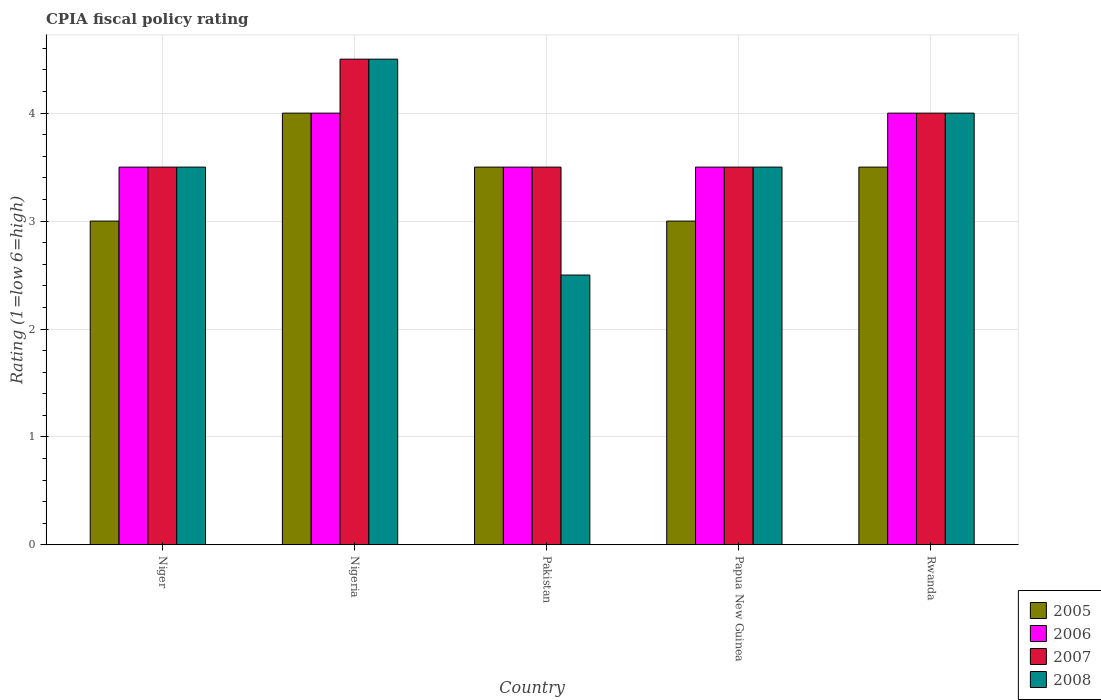How many different coloured bars are there?
Your response must be concise. 4. How many groups of bars are there?
Offer a very short reply. 5. Are the number of bars per tick equal to the number of legend labels?
Ensure brevity in your answer.  Yes. How many bars are there on the 5th tick from the left?
Ensure brevity in your answer.  4. What is the label of the 5th group of bars from the left?
Provide a short and direct response. Rwanda. In which country was the CPIA rating in 2008 maximum?
Provide a succinct answer. Nigeria. In which country was the CPIA rating in 2007 minimum?
Your answer should be very brief. Niger. What is the difference between the CPIA rating in 2008 in Papua New Guinea and that in Rwanda?
Provide a short and direct response. -0.5. What is the difference between the CPIA rating in 2006 in Papua New Guinea and the CPIA rating in 2007 in Niger?
Your response must be concise. 0. What is the average CPIA rating in 2007 per country?
Provide a short and direct response. 3.8. In how many countries, is the CPIA rating in 2007 greater than 4?
Make the answer very short. 1. What is the ratio of the CPIA rating in 2005 in Nigeria to that in Rwanda?
Offer a terse response. 1.14. Is the sum of the CPIA rating in 2006 in Niger and Nigeria greater than the maximum CPIA rating in 2007 across all countries?
Make the answer very short. Yes. Is it the case that in every country, the sum of the CPIA rating in 2006 and CPIA rating in 2007 is greater than the sum of CPIA rating in 2008 and CPIA rating in 2005?
Provide a short and direct response. No. Is it the case that in every country, the sum of the CPIA rating in 2007 and CPIA rating in 2006 is greater than the CPIA rating in 2008?
Provide a short and direct response. Yes. What is the difference between two consecutive major ticks on the Y-axis?
Your response must be concise. 1. How many legend labels are there?
Provide a short and direct response. 4. How are the legend labels stacked?
Your response must be concise. Vertical. What is the title of the graph?
Keep it short and to the point. CPIA fiscal policy rating. Does "1998" appear as one of the legend labels in the graph?
Your response must be concise. No. What is the label or title of the X-axis?
Give a very brief answer. Country. What is the label or title of the Y-axis?
Provide a succinct answer. Rating (1=low 6=high). What is the Rating (1=low 6=high) in 2006 in Nigeria?
Provide a short and direct response. 4. What is the Rating (1=low 6=high) of 2008 in Nigeria?
Offer a terse response. 4.5. What is the Rating (1=low 6=high) in 2005 in Pakistan?
Keep it short and to the point. 3.5. What is the Rating (1=low 6=high) of 2007 in Pakistan?
Your answer should be very brief. 3.5. What is the Rating (1=low 6=high) of 2006 in Papua New Guinea?
Give a very brief answer. 3.5. What is the Rating (1=low 6=high) of 2007 in Papua New Guinea?
Offer a terse response. 3.5. What is the Rating (1=low 6=high) in 2006 in Rwanda?
Offer a terse response. 4. What is the Rating (1=low 6=high) of 2007 in Rwanda?
Your answer should be very brief. 4. Across all countries, what is the maximum Rating (1=low 6=high) of 2006?
Provide a short and direct response. 4. Across all countries, what is the maximum Rating (1=low 6=high) in 2008?
Your answer should be very brief. 4.5. Across all countries, what is the minimum Rating (1=low 6=high) of 2005?
Provide a succinct answer. 3. Across all countries, what is the minimum Rating (1=low 6=high) of 2007?
Give a very brief answer. 3.5. Across all countries, what is the minimum Rating (1=low 6=high) in 2008?
Give a very brief answer. 2.5. What is the total Rating (1=low 6=high) of 2005 in the graph?
Give a very brief answer. 17. What is the total Rating (1=low 6=high) of 2006 in the graph?
Ensure brevity in your answer.  18.5. What is the difference between the Rating (1=low 6=high) of 2005 in Niger and that in Nigeria?
Provide a short and direct response. -1. What is the difference between the Rating (1=low 6=high) in 2007 in Niger and that in Nigeria?
Offer a very short reply. -1. What is the difference between the Rating (1=low 6=high) of 2008 in Niger and that in Nigeria?
Your response must be concise. -1. What is the difference between the Rating (1=low 6=high) in 2006 in Niger and that in Pakistan?
Ensure brevity in your answer.  0. What is the difference between the Rating (1=low 6=high) of 2007 in Niger and that in Pakistan?
Offer a terse response. 0. What is the difference between the Rating (1=low 6=high) of 2005 in Niger and that in Papua New Guinea?
Keep it short and to the point. 0. What is the difference between the Rating (1=low 6=high) of 2007 in Niger and that in Papua New Guinea?
Your answer should be very brief. 0. What is the difference between the Rating (1=low 6=high) of 2008 in Niger and that in Papua New Guinea?
Ensure brevity in your answer.  0. What is the difference between the Rating (1=low 6=high) of 2006 in Niger and that in Rwanda?
Ensure brevity in your answer.  -0.5. What is the difference between the Rating (1=low 6=high) in 2007 in Niger and that in Rwanda?
Your answer should be very brief. -0.5. What is the difference between the Rating (1=low 6=high) in 2008 in Niger and that in Rwanda?
Provide a succinct answer. -0.5. What is the difference between the Rating (1=low 6=high) of 2005 in Nigeria and that in Pakistan?
Ensure brevity in your answer.  0.5. What is the difference between the Rating (1=low 6=high) of 2006 in Nigeria and that in Pakistan?
Your response must be concise. 0.5. What is the difference between the Rating (1=low 6=high) in 2007 in Nigeria and that in Pakistan?
Give a very brief answer. 1. What is the difference between the Rating (1=low 6=high) in 2006 in Nigeria and that in Papua New Guinea?
Ensure brevity in your answer.  0.5. What is the difference between the Rating (1=low 6=high) in 2007 in Nigeria and that in Papua New Guinea?
Your response must be concise. 1. What is the difference between the Rating (1=low 6=high) of 2005 in Nigeria and that in Rwanda?
Make the answer very short. 0.5. What is the difference between the Rating (1=low 6=high) of 2007 in Nigeria and that in Rwanda?
Offer a terse response. 0.5. What is the difference between the Rating (1=low 6=high) in 2008 in Nigeria and that in Rwanda?
Ensure brevity in your answer.  0.5. What is the difference between the Rating (1=low 6=high) in 2005 in Pakistan and that in Papua New Guinea?
Keep it short and to the point. 0.5. What is the difference between the Rating (1=low 6=high) of 2006 in Pakistan and that in Papua New Guinea?
Provide a short and direct response. 0. What is the difference between the Rating (1=low 6=high) in 2007 in Pakistan and that in Papua New Guinea?
Your answer should be compact. 0. What is the difference between the Rating (1=low 6=high) in 2005 in Pakistan and that in Rwanda?
Your response must be concise. 0. What is the difference between the Rating (1=low 6=high) in 2006 in Pakistan and that in Rwanda?
Offer a very short reply. -0.5. What is the difference between the Rating (1=low 6=high) in 2007 in Pakistan and that in Rwanda?
Offer a very short reply. -0.5. What is the difference between the Rating (1=low 6=high) in 2008 in Pakistan and that in Rwanda?
Offer a terse response. -1.5. What is the difference between the Rating (1=low 6=high) of 2006 in Papua New Guinea and that in Rwanda?
Your answer should be compact. -0.5. What is the difference between the Rating (1=low 6=high) of 2007 in Papua New Guinea and that in Rwanda?
Offer a terse response. -0.5. What is the difference between the Rating (1=low 6=high) in 2008 in Papua New Guinea and that in Rwanda?
Make the answer very short. -0.5. What is the difference between the Rating (1=low 6=high) in 2005 in Niger and the Rating (1=low 6=high) in 2008 in Nigeria?
Offer a terse response. -1.5. What is the difference between the Rating (1=low 6=high) in 2006 in Niger and the Rating (1=low 6=high) in 2007 in Nigeria?
Offer a terse response. -1. What is the difference between the Rating (1=low 6=high) in 2007 in Niger and the Rating (1=low 6=high) in 2008 in Nigeria?
Your response must be concise. -1. What is the difference between the Rating (1=low 6=high) of 2005 in Niger and the Rating (1=low 6=high) of 2007 in Pakistan?
Provide a short and direct response. -0.5. What is the difference between the Rating (1=low 6=high) of 2005 in Niger and the Rating (1=low 6=high) of 2006 in Papua New Guinea?
Your answer should be very brief. -0.5. What is the difference between the Rating (1=low 6=high) of 2005 in Niger and the Rating (1=low 6=high) of 2007 in Papua New Guinea?
Provide a short and direct response. -0.5. What is the difference between the Rating (1=low 6=high) of 2005 in Niger and the Rating (1=low 6=high) of 2008 in Papua New Guinea?
Offer a terse response. -0.5. What is the difference between the Rating (1=low 6=high) of 2006 in Niger and the Rating (1=low 6=high) of 2007 in Papua New Guinea?
Provide a succinct answer. 0. What is the difference between the Rating (1=low 6=high) of 2007 in Niger and the Rating (1=low 6=high) of 2008 in Papua New Guinea?
Offer a very short reply. 0. What is the difference between the Rating (1=low 6=high) in 2005 in Niger and the Rating (1=low 6=high) in 2007 in Rwanda?
Your answer should be very brief. -1. What is the difference between the Rating (1=low 6=high) in 2005 in Niger and the Rating (1=low 6=high) in 2008 in Rwanda?
Your answer should be compact. -1. What is the difference between the Rating (1=low 6=high) in 2006 in Niger and the Rating (1=low 6=high) in 2007 in Rwanda?
Ensure brevity in your answer.  -0.5. What is the difference between the Rating (1=low 6=high) of 2007 in Niger and the Rating (1=low 6=high) of 2008 in Rwanda?
Offer a terse response. -0.5. What is the difference between the Rating (1=low 6=high) in 2005 in Nigeria and the Rating (1=low 6=high) in 2007 in Pakistan?
Your answer should be compact. 0.5. What is the difference between the Rating (1=low 6=high) in 2006 in Nigeria and the Rating (1=low 6=high) in 2008 in Pakistan?
Your answer should be compact. 1.5. What is the difference between the Rating (1=low 6=high) in 2005 in Nigeria and the Rating (1=low 6=high) in 2006 in Papua New Guinea?
Ensure brevity in your answer.  0.5. What is the difference between the Rating (1=low 6=high) of 2005 in Nigeria and the Rating (1=low 6=high) of 2007 in Papua New Guinea?
Your answer should be compact. 0.5. What is the difference between the Rating (1=low 6=high) in 2005 in Nigeria and the Rating (1=low 6=high) in 2008 in Papua New Guinea?
Provide a succinct answer. 0.5. What is the difference between the Rating (1=low 6=high) in 2006 in Nigeria and the Rating (1=low 6=high) in 2007 in Papua New Guinea?
Offer a very short reply. 0.5. What is the difference between the Rating (1=low 6=high) in 2006 in Nigeria and the Rating (1=low 6=high) in 2008 in Papua New Guinea?
Your response must be concise. 0.5. What is the difference between the Rating (1=low 6=high) of 2007 in Nigeria and the Rating (1=low 6=high) of 2008 in Papua New Guinea?
Keep it short and to the point. 1. What is the difference between the Rating (1=low 6=high) of 2005 in Nigeria and the Rating (1=low 6=high) of 2006 in Rwanda?
Your answer should be very brief. 0. What is the difference between the Rating (1=low 6=high) of 2006 in Nigeria and the Rating (1=low 6=high) of 2007 in Rwanda?
Offer a very short reply. 0. What is the difference between the Rating (1=low 6=high) of 2006 in Nigeria and the Rating (1=low 6=high) of 2008 in Rwanda?
Your response must be concise. 0. What is the difference between the Rating (1=low 6=high) of 2007 in Nigeria and the Rating (1=low 6=high) of 2008 in Rwanda?
Offer a very short reply. 0.5. What is the difference between the Rating (1=low 6=high) of 2005 in Pakistan and the Rating (1=low 6=high) of 2006 in Papua New Guinea?
Provide a succinct answer. 0. What is the difference between the Rating (1=low 6=high) of 2005 in Pakistan and the Rating (1=low 6=high) of 2007 in Papua New Guinea?
Your response must be concise. 0. What is the difference between the Rating (1=low 6=high) in 2006 in Pakistan and the Rating (1=low 6=high) in 2007 in Papua New Guinea?
Your response must be concise. 0. What is the difference between the Rating (1=low 6=high) of 2006 in Pakistan and the Rating (1=low 6=high) of 2008 in Papua New Guinea?
Your answer should be compact. 0. What is the difference between the Rating (1=low 6=high) of 2005 in Pakistan and the Rating (1=low 6=high) of 2007 in Rwanda?
Your answer should be very brief. -0.5. What is the difference between the Rating (1=low 6=high) in 2005 in Pakistan and the Rating (1=low 6=high) in 2008 in Rwanda?
Your response must be concise. -0.5. What is the difference between the Rating (1=low 6=high) of 2005 in Papua New Guinea and the Rating (1=low 6=high) of 2007 in Rwanda?
Your answer should be compact. -1. What is the difference between the Rating (1=low 6=high) in 2005 in Papua New Guinea and the Rating (1=low 6=high) in 2008 in Rwanda?
Provide a succinct answer. -1. What is the average Rating (1=low 6=high) in 2006 per country?
Your answer should be compact. 3.7. What is the average Rating (1=low 6=high) in 2007 per country?
Provide a short and direct response. 3.8. What is the average Rating (1=low 6=high) of 2008 per country?
Your answer should be compact. 3.6. What is the difference between the Rating (1=low 6=high) of 2005 and Rating (1=low 6=high) of 2007 in Niger?
Your answer should be very brief. -0.5. What is the difference between the Rating (1=low 6=high) in 2005 and Rating (1=low 6=high) in 2008 in Niger?
Your response must be concise. -0.5. What is the difference between the Rating (1=low 6=high) in 2006 and Rating (1=low 6=high) in 2007 in Niger?
Offer a very short reply. 0. What is the difference between the Rating (1=low 6=high) in 2005 and Rating (1=low 6=high) in 2006 in Nigeria?
Offer a terse response. 0. What is the difference between the Rating (1=low 6=high) of 2005 and Rating (1=low 6=high) of 2007 in Nigeria?
Ensure brevity in your answer.  -0.5. What is the difference between the Rating (1=low 6=high) of 2006 and Rating (1=low 6=high) of 2008 in Nigeria?
Offer a terse response. -0.5. What is the difference between the Rating (1=low 6=high) in 2005 and Rating (1=low 6=high) in 2007 in Pakistan?
Give a very brief answer. 0. What is the difference between the Rating (1=low 6=high) in 2006 and Rating (1=low 6=high) in 2007 in Pakistan?
Offer a very short reply. 0. What is the difference between the Rating (1=low 6=high) in 2005 and Rating (1=low 6=high) in 2008 in Papua New Guinea?
Make the answer very short. -0.5. What is the difference between the Rating (1=low 6=high) in 2006 and Rating (1=low 6=high) in 2007 in Papua New Guinea?
Give a very brief answer. 0. What is the difference between the Rating (1=low 6=high) of 2007 and Rating (1=low 6=high) of 2008 in Papua New Guinea?
Offer a very short reply. 0. What is the difference between the Rating (1=low 6=high) in 2005 and Rating (1=low 6=high) in 2006 in Rwanda?
Your answer should be very brief. -0.5. What is the difference between the Rating (1=low 6=high) in 2005 and Rating (1=low 6=high) in 2007 in Rwanda?
Make the answer very short. -0.5. What is the difference between the Rating (1=low 6=high) of 2005 and Rating (1=low 6=high) of 2008 in Rwanda?
Provide a short and direct response. -0.5. What is the difference between the Rating (1=low 6=high) in 2006 and Rating (1=low 6=high) in 2007 in Rwanda?
Keep it short and to the point. 0. What is the difference between the Rating (1=low 6=high) in 2006 and Rating (1=low 6=high) in 2008 in Rwanda?
Your response must be concise. 0. What is the ratio of the Rating (1=low 6=high) in 2005 in Niger to that in Nigeria?
Your answer should be very brief. 0.75. What is the ratio of the Rating (1=low 6=high) of 2006 in Niger to that in Nigeria?
Make the answer very short. 0.88. What is the ratio of the Rating (1=low 6=high) of 2007 in Niger to that in Nigeria?
Give a very brief answer. 0.78. What is the ratio of the Rating (1=low 6=high) in 2005 in Niger to that in Pakistan?
Your answer should be compact. 0.86. What is the ratio of the Rating (1=low 6=high) in 2007 in Niger to that in Pakistan?
Your response must be concise. 1. What is the ratio of the Rating (1=low 6=high) of 2008 in Niger to that in Pakistan?
Offer a very short reply. 1.4. What is the ratio of the Rating (1=low 6=high) in 2006 in Niger to that in Papua New Guinea?
Your answer should be compact. 1. What is the ratio of the Rating (1=low 6=high) in 2007 in Niger to that in Papua New Guinea?
Provide a short and direct response. 1. What is the ratio of the Rating (1=low 6=high) of 2005 in Niger to that in Rwanda?
Your answer should be compact. 0.86. What is the ratio of the Rating (1=low 6=high) of 2006 in Nigeria to that in Pakistan?
Your response must be concise. 1.14. What is the ratio of the Rating (1=low 6=high) in 2007 in Nigeria to that in Papua New Guinea?
Provide a succinct answer. 1.29. What is the ratio of the Rating (1=low 6=high) in 2005 in Nigeria to that in Rwanda?
Offer a very short reply. 1.14. What is the ratio of the Rating (1=low 6=high) of 2006 in Nigeria to that in Rwanda?
Offer a very short reply. 1. What is the ratio of the Rating (1=low 6=high) of 2007 in Nigeria to that in Rwanda?
Offer a terse response. 1.12. What is the ratio of the Rating (1=low 6=high) of 2005 in Pakistan to that in Papua New Guinea?
Keep it short and to the point. 1.17. What is the ratio of the Rating (1=low 6=high) of 2006 in Pakistan to that in Papua New Guinea?
Give a very brief answer. 1. What is the ratio of the Rating (1=low 6=high) in 2007 in Pakistan to that in Papua New Guinea?
Ensure brevity in your answer.  1. What is the ratio of the Rating (1=low 6=high) of 2008 in Pakistan to that in Papua New Guinea?
Offer a very short reply. 0.71. What is the ratio of the Rating (1=low 6=high) in 2006 in Pakistan to that in Rwanda?
Your response must be concise. 0.88. What is the ratio of the Rating (1=low 6=high) of 2008 in Pakistan to that in Rwanda?
Your response must be concise. 0.62. What is the ratio of the Rating (1=low 6=high) in 2006 in Papua New Guinea to that in Rwanda?
Your response must be concise. 0.88. What is the ratio of the Rating (1=low 6=high) of 2008 in Papua New Guinea to that in Rwanda?
Make the answer very short. 0.88. What is the difference between the highest and the second highest Rating (1=low 6=high) of 2005?
Provide a short and direct response. 0.5. What is the difference between the highest and the second highest Rating (1=low 6=high) in 2006?
Your answer should be compact. 0. What is the difference between the highest and the lowest Rating (1=low 6=high) of 2006?
Ensure brevity in your answer.  0.5. What is the difference between the highest and the lowest Rating (1=low 6=high) in 2007?
Give a very brief answer. 1. What is the difference between the highest and the lowest Rating (1=low 6=high) in 2008?
Your answer should be very brief. 2. 